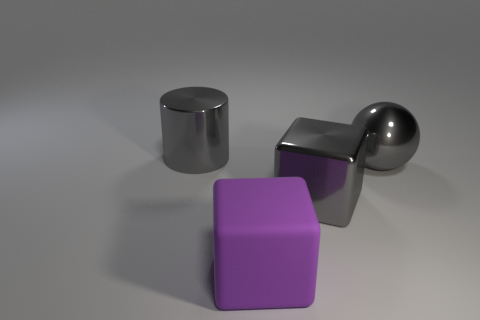What is the block that is behind the big purple block made of?
Your response must be concise. Metal. How many other objects are there of the same size as the sphere?
Offer a terse response. 3. There is a purple thing; is its size the same as the gray shiny object behind the shiny sphere?
Offer a very short reply. Yes. What shape is the gray thing that is to the left of the purple rubber block that is in front of the large cube to the right of the big matte object?
Provide a succinct answer. Cylinder. Are there fewer rubber things than big objects?
Give a very brief answer. Yes. Are there any shiny things to the left of the cylinder?
Offer a terse response. No. There is a object that is to the right of the purple cube and in front of the gray sphere; what is its shape?
Give a very brief answer. Cube. Are there any other large objects of the same shape as the large purple thing?
Your response must be concise. Yes. Does the metal object that is left of the purple rubber thing have the same size as the gray metal object that is to the right of the gray cube?
Your answer should be very brief. Yes. Are there more metal cubes than small yellow rubber objects?
Your response must be concise. Yes. 